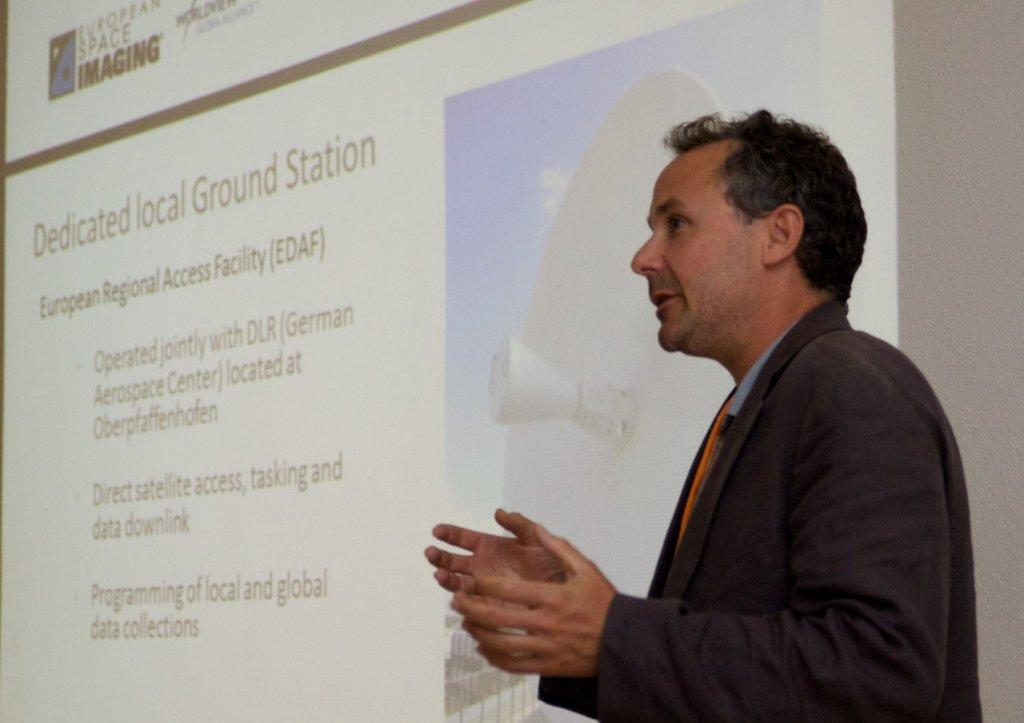Who is present in the image? There is a man in the image. What is the man wearing? The man is wearing black. What is the man doing in the image? The man is standing and explaining something. What can be seen behind the man in the image? There is a white color projector screen in the image. What type of hate can be seen on the man's face in the image? There is no indication of hate on the man's face in the image. Does the man have a tail in the image? The man does not have a tail in the image. 